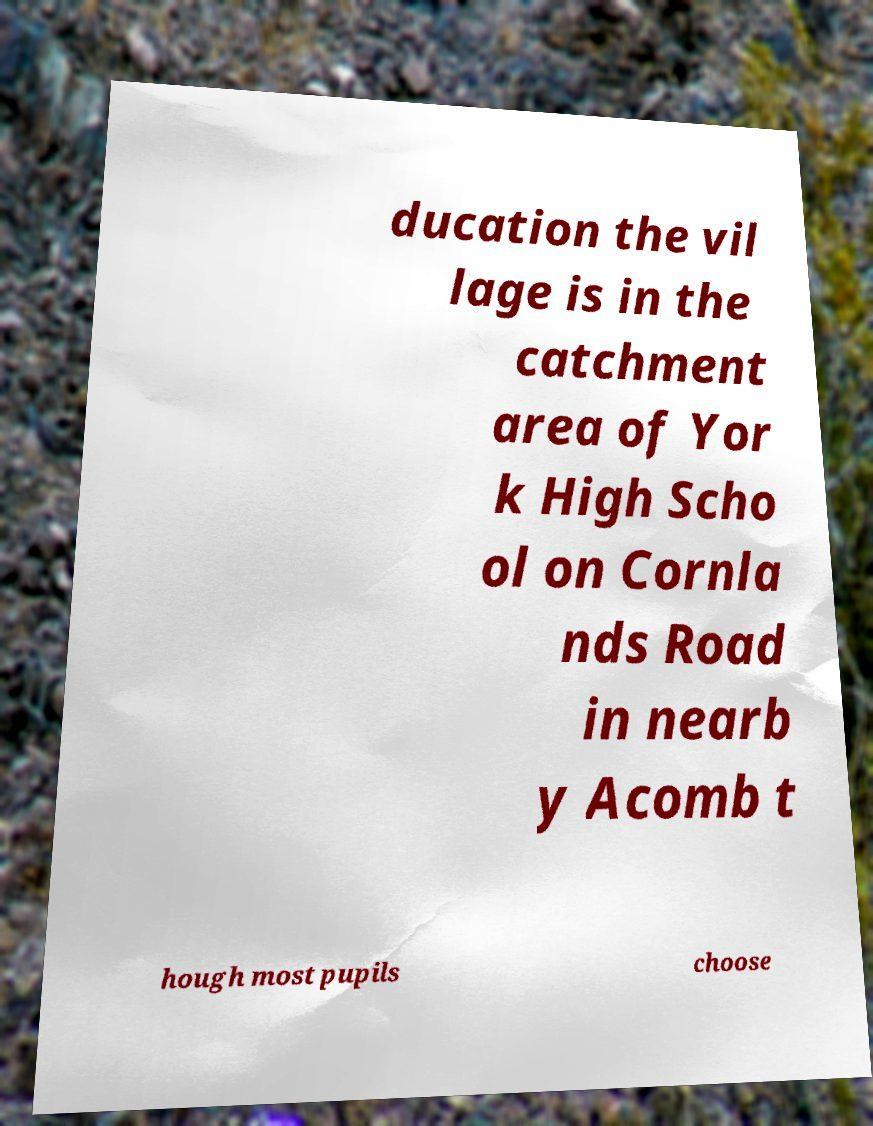Could you assist in decoding the text presented in this image and type it out clearly? ducation the vil lage is in the catchment area of Yor k High Scho ol on Cornla nds Road in nearb y Acomb t hough most pupils choose 